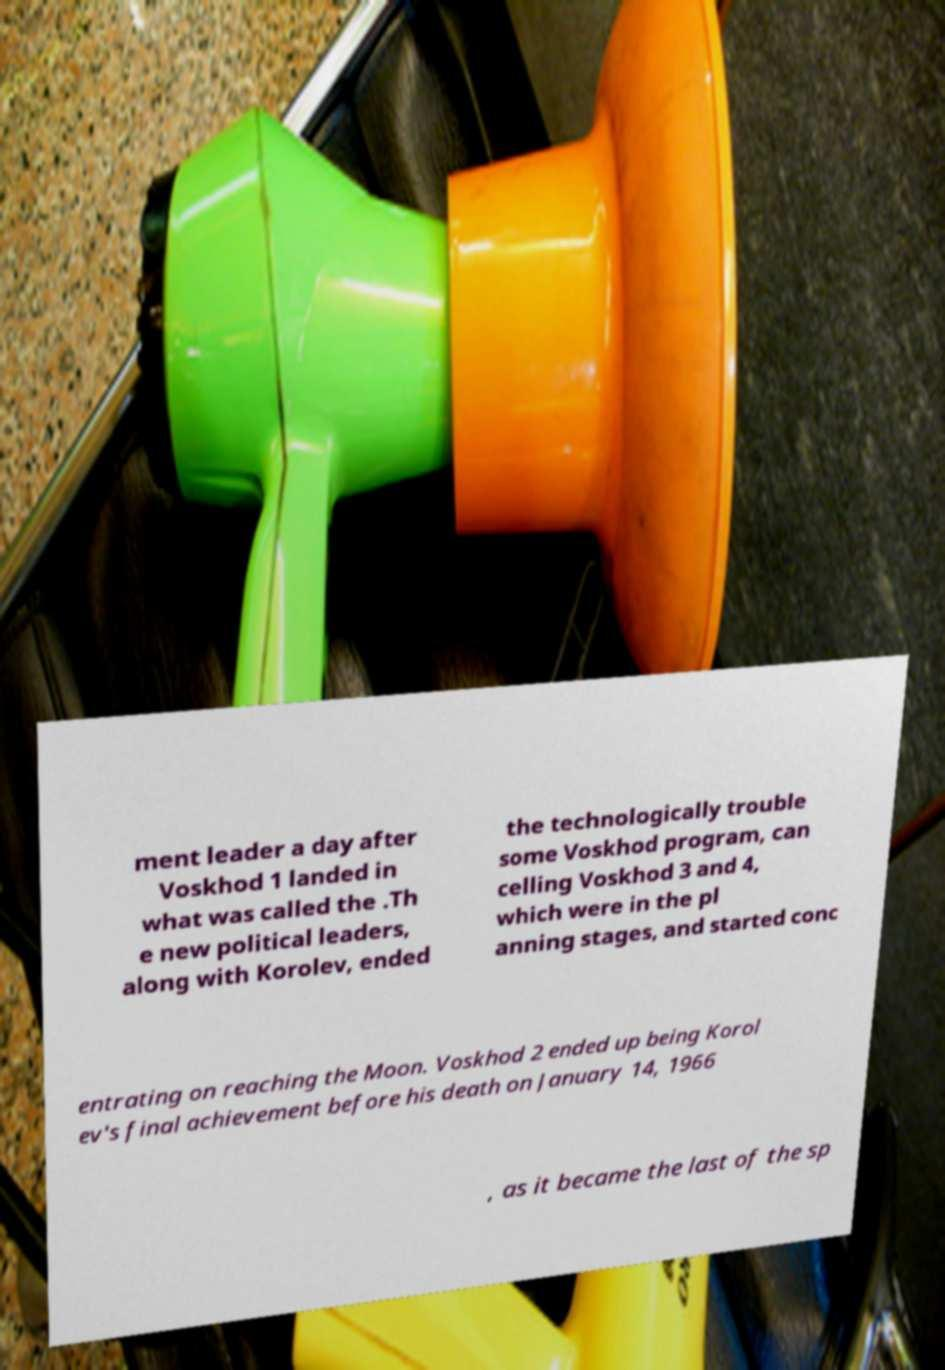I need the written content from this picture converted into text. Can you do that? ment leader a day after Voskhod 1 landed in what was called the .Th e new political leaders, along with Korolev, ended the technologically trouble some Voskhod program, can celling Voskhod 3 and 4, which were in the pl anning stages, and started conc entrating on reaching the Moon. Voskhod 2 ended up being Korol ev's final achievement before his death on January 14, 1966 , as it became the last of the sp 